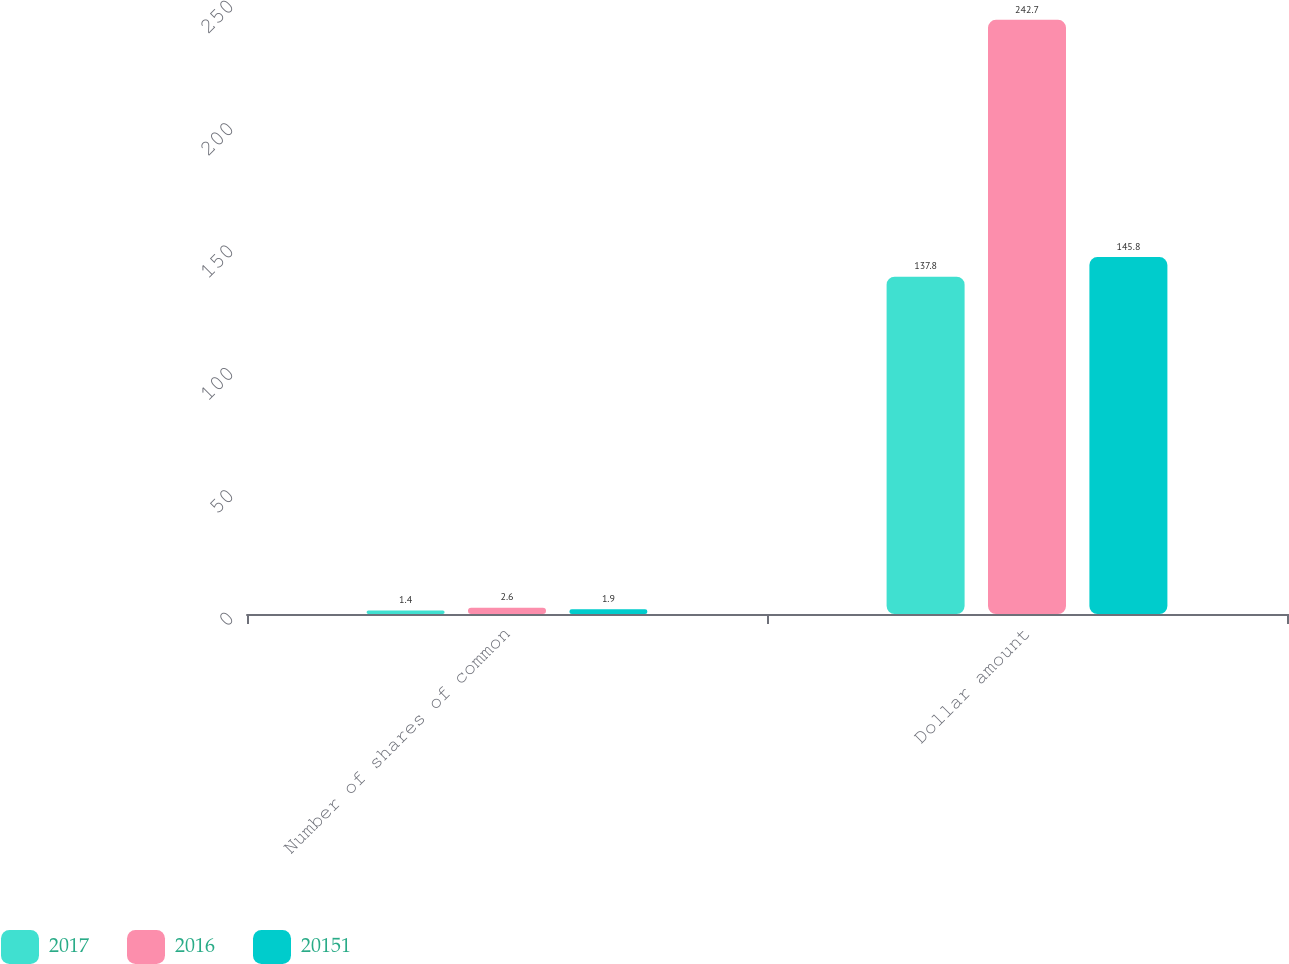<chart> <loc_0><loc_0><loc_500><loc_500><stacked_bar_chart><ecel><fcel>Number of shares of common<fcel>Dollar amount<nl><fcel>2017<fcel>1.4<fcel>137.8<nl><fcel>2016<fcel>2.6<fcel>242.7<nl><fcel>20151<fcel>1.9<fcel>145.8<nl></chart> 